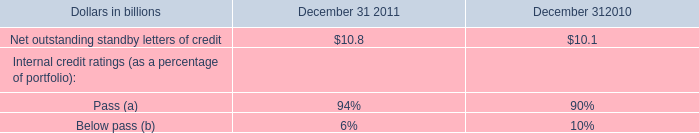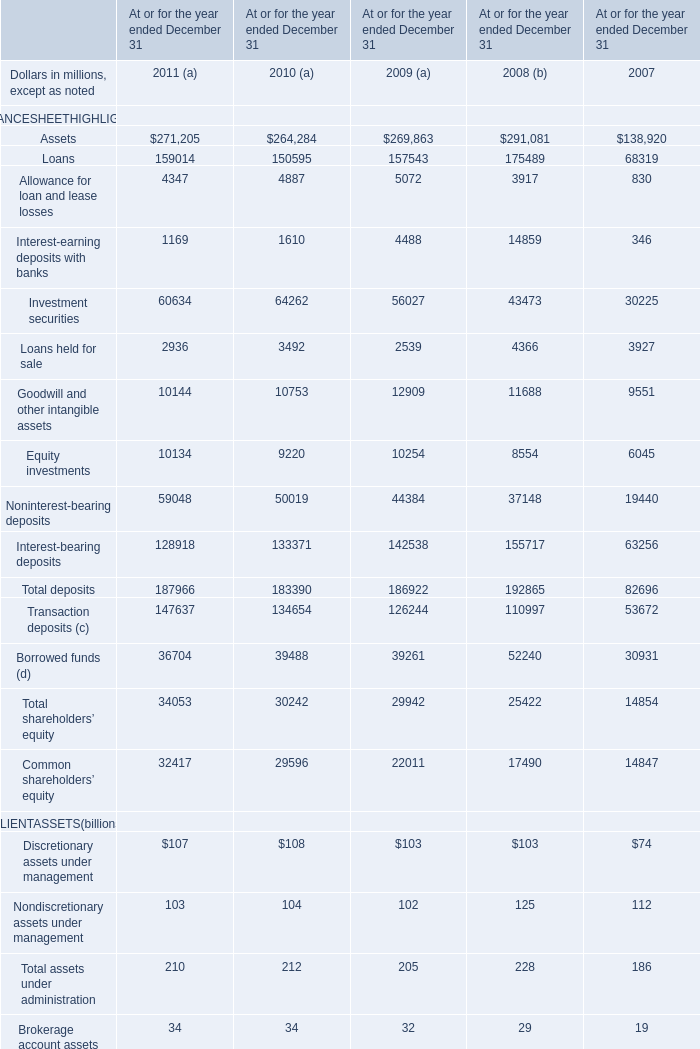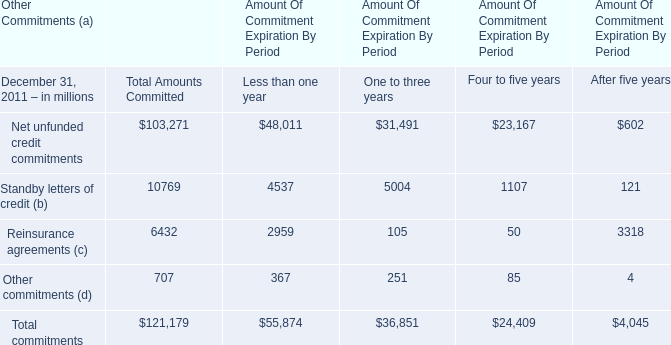How many CLIENTASSETS exceed the average of CLIENTASSETS in 2009? 
Answer: 2. 